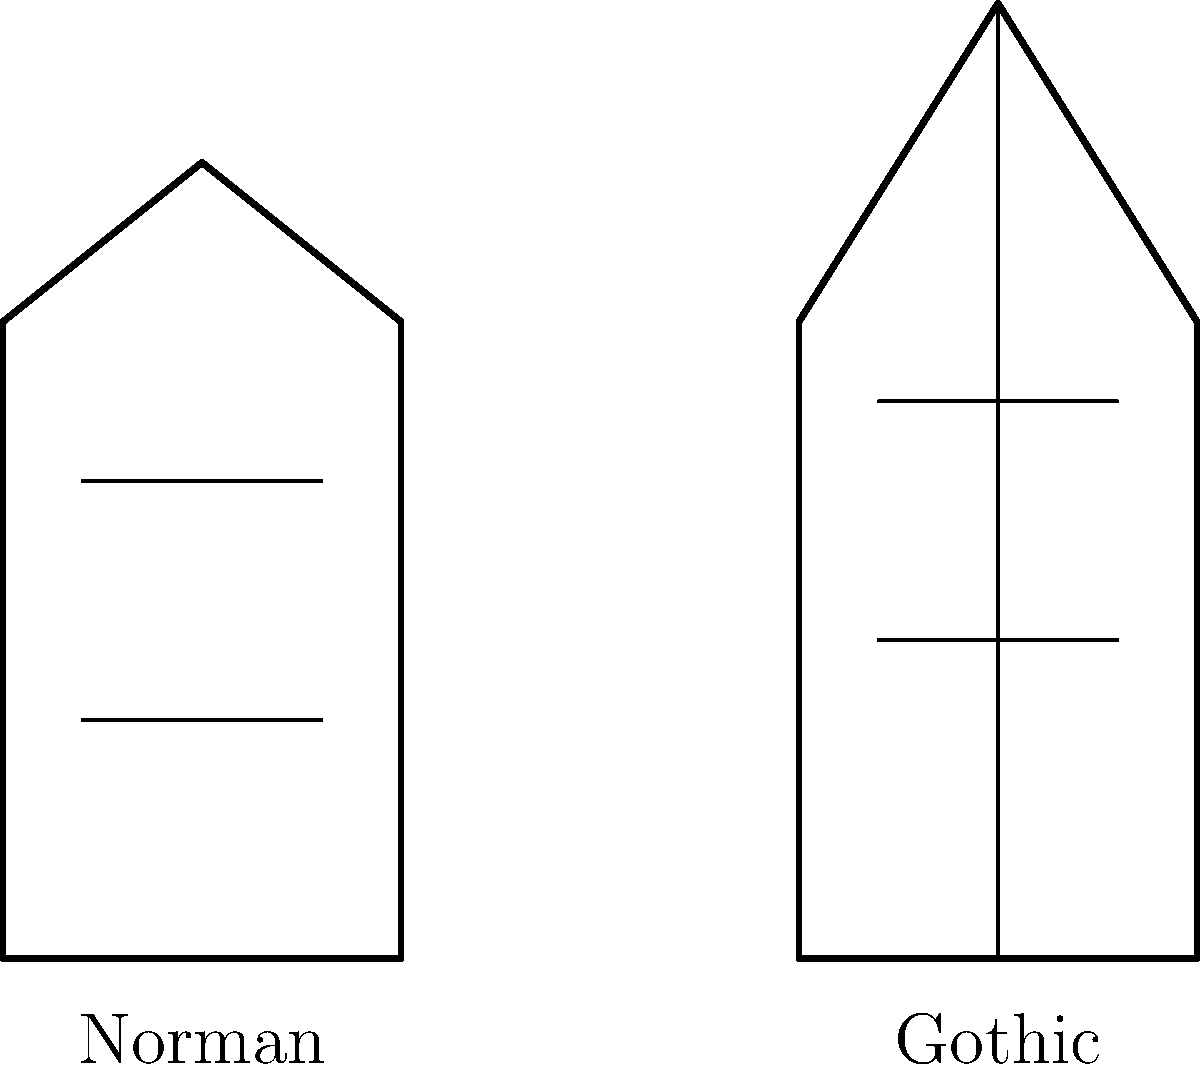Compare the architectural features of Norman and Gothic styles as seen in Durham Cathedral. Which style is characterized by rounded arches and which by pointed arches? To answer this question, let's examine the key features of Norman and Gothic architectural styles as depicted in the simplified sketches:

1. Norman style (left sketch):
   - Characterized by thick, sturdy walls
   - Round-headed arches
   - Small, narrow windows
   - Overall appearance is heavy and fortress-like

2. Gothic style (right sketch):
   - Characterized by taller, more slender structures
   - Pointed arches
   - Larger windows, often with tracery
   - Overall appearance is lighter and more vertical

In the context of Durham Cathedral:

3. The original structure of Durham Cathedral, built in the late 11th and early 12th centuries, is primarily Norman in style.
   - The nave and transepts feature round-headed arches typical of Norman architecture

4. Gothic elements were added later, particularly in the 13th century:
   - The Chapel of the Nine Altars, added to the east end, features pointed arches and large windows typical of Gothic style

5. The key distinguishing feature between these styles is the shape of the arches:
   - Norman arches are rounded
   - Gothic arches are pointed

Therefore, the Norman style is characterized by rounded arches, while the Gothic style is characterized by pointed arches.
Answer: Norman: rounded arches; Gothic: pointed arches 